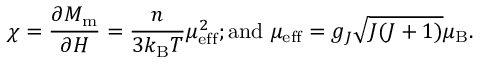Convert formula to latex. <formula><loc_0><loc_0><loc_500><loc_500>\chi = { \frac { \partial M _ { m } } { \partial H } } = { \frac { n } { 3 k _ { B } T } } \mu _ { e f f } ^ { 2 } { ; a n d } \mu _ { e f f } = g _ { J } { \sqrt { J ( J + 1 ) } } \mu _ { B } .</formula> 